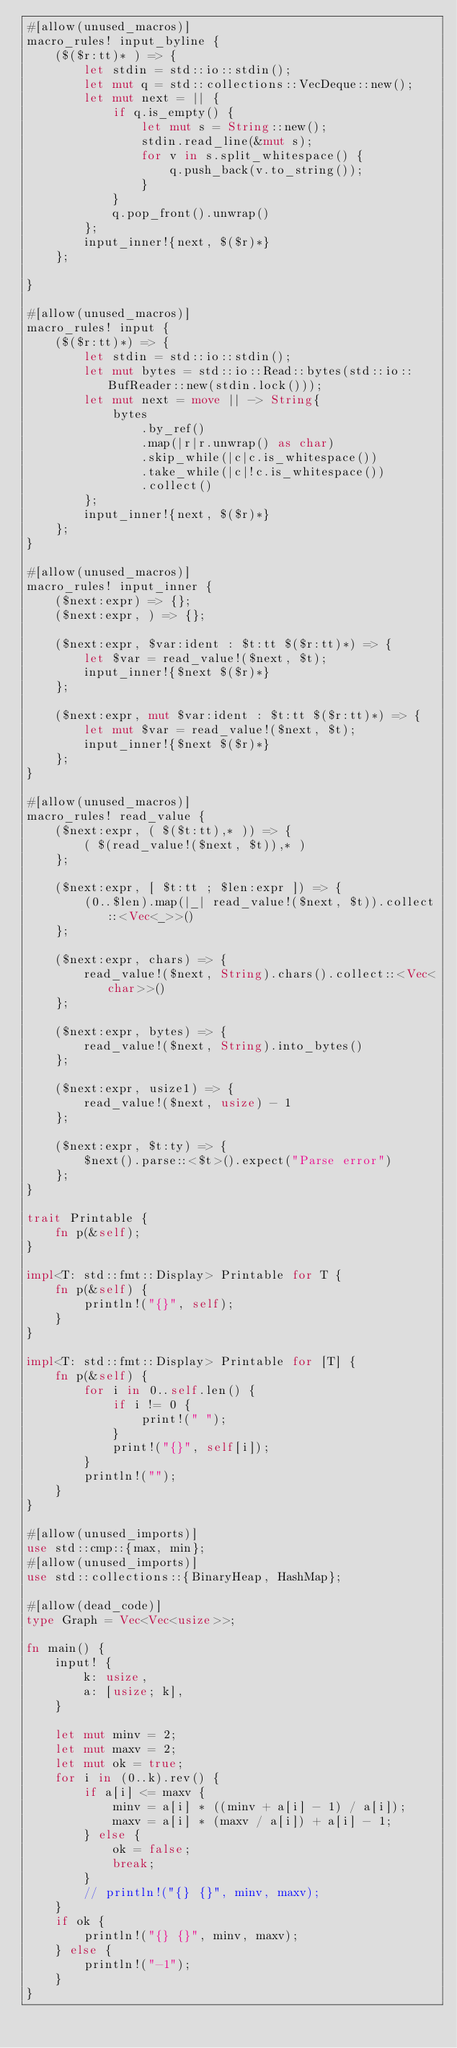Convert code to text. <code><loc_0><loc_0><loc_500><loc_500><_Rust_>#[allow(unused_macros)]
macro_rules! input_byline {
    ($($r:tt)* ) => {
        let stdin = std::io::stdin();
        let mut q = std::collections::VecDeque::new();
        let mut next = || {
            if q.is_empty() {
                let mut s = String::new();
                stdin.read_line(&mut s);
                for v in s.split_whitespace() {
                    q.push_back(v.to_string());
                }
            }
            q.pop_front().unwrap()
        };
        input_inner!{next, $($r)*}
    };

}

#[allow(unused_macros)]
macro_rules! input {
    ($($r:tt)*) => {
        let stdin = std::io::stdin();
        let mut bytes = std::io::Read::bytes(std::io::BufReader::new(stdin.lock()));
        let mut next = move || -> String{
            bytes
                .by_ref()
                .map(|r|r.unwrap() as char)
                .skip_while(|c|c.is_whitespace())
                .take_while(|c|!c.is_whitespace())
                .collect()
        };
        input_inner!{next, $($r)*}
    };
}

#[allow(unused_macros)]
macro_rules! input_inner {
    ($next:expr) => {};
    ($next:expr, ) => {};

    ($next:expr, $var:ident : $t:tt $($r:tt)*) => {
        let $var = read_value!($next, $t);
        input_inner!{$next $($r)*}
    };

    ($next:expr, mut $var:ident : $t:tt $($r:tt)*) => {
        let mut $var = read_value!($next, $t);
        input_inner!{$next $($r)*}
    };
}

#[allow(unused_macros)]
macro_rules! read_value {
    ($next:expr, ( $($t:tt),* )) => {
        ( $(read_value!($next, $t)),* )
    };

    ($next:expr, [ $t:tt ; $len:expr ]) => {
        (0..$len).map(|_| read_value!($next, $t)).collect::<Vec<_>>()
    };

    ($next:expr, chars) => {
        read_value!($next, String).chars().collect::<Vec<char>>()
    };

    ($next:expr, bytes) => {
        read_value!($next, String).into_bytes()
    };

    ($next:expr, usize1) => {
        read_value!($next, usize) - 1
    };

    ($next:expr, $t:ty) => {
        $next().parse::<$t>().expect("Parse error")
    };
}

trait Printable {
    fn p(&self);
}

impl<T: std::fmt::Display> Printable for T {
    fn p(&self) {
        println!("{}", self);
    }
}

impl<T: std::fmt::Display> Printable for [T] {
    fn p(&self) {
        for i in 0..self.len() {
            if i != 0 {
                print!(" ");
            }
            print!("{}", self[i]);
        }
        println!("");
    }
}

#[allow(unused_imports)]
use std::cmp::{max, min};
#[allow(unused_imports)]
use std::collections::{BinaryHeap, HashMap};

#[allow(dead_code)]
type Graph = Vec<Vec<usize>>;

fn main() {
    input! {
        k: usize,
        a: [usize; k],
    }

    let mut minv = 2;
    let mut maxv = 2;
    let mut ok = true;
    for i in (0..k).rev() {
        if a[i] <= maxv {
            minv = a[i] * ((minv + a[i] - 1) / a[i]);
            maxv = a[i] * (maxv / a[i]) + a[i] - 1;
        } else {
            ok = false;
            break;
        }
        // println!("{} {}", minv, maxv);
    }
    if ok {
        println!("{} {}", minv, maxv);
    } else {
        println!("-1");
    }
}
</code> 